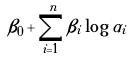Convert formula to latex. <formula><loc_0><loc_0><loc_500><loc_500>\beta _ { 0 } + \sum _ { i = 1 } ^ { n } \beta _ { i } \log \alpha _ { i }</formula> 